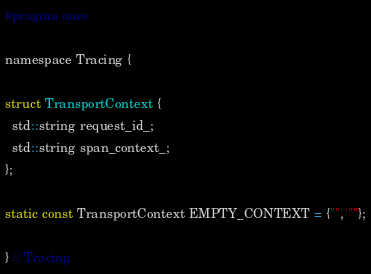<code> <loc_0><loc_0><loc_500><loc_500><_C_>#pragma once

namespace Tracing {

struct TransportContext {
  std::string request_id_;
  std::string span_context_;
};

static const TransportContext EMPTY_CONTEXT = {"", ""};

} // Tracing</code> 